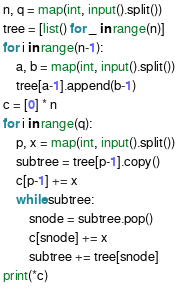<code> <loc_0><loc_0><loc_500><loc_500><_Python_>n, q = map(int, input().split())
tree = [list() for _ in range(n)]
for i in range(n-1):
    a, b = map(int, input().split())
    tree[a-1].append(b-1)
c = [0] * n
for i in range(q):
    p, x = map(int, input().split())
    subtree = tree[p-1].copy()
    c[p-1] += x
    while subtree:
        snode = subtree.pop()
        c[snode] += x
        subtree += tree[snode]
print(*c)
</code> 